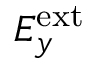Convert formula to latex. <formula><loc_0><loc_0><loc_500><loc_500>E _ { y } ^ { e x t }</formula> 